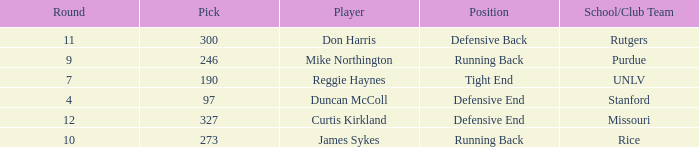What is the highest round number for the player who came from team Missouri? 12.0. 